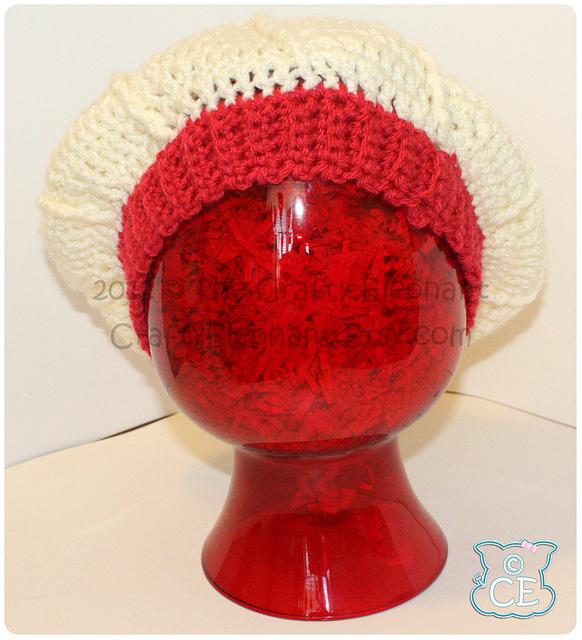Is this a knitted hat?
Quick response, please. Yes. What color is the hat?
Short answer required. White and red. What colors are the hat?
Be succinct. White and red. What is the hat on?
Short answer required. Bowling ball. What was used to make this hat?
Quick response, please. Yarn. 